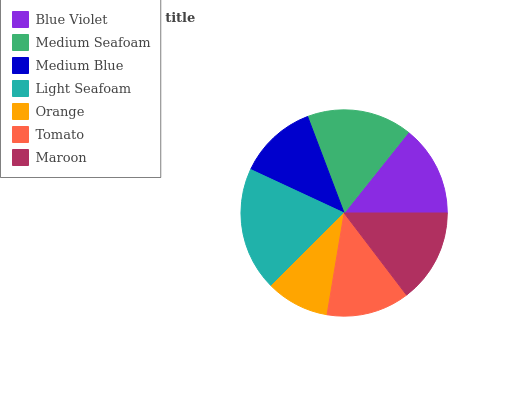Is Orange the minimum?
Answer yes or no. Yes. Is Light Seafoam the maximum?
Answer yes or no. Yes. Is Medium Seafoam the minimum?
Answer yes or no. No. Is Medium Seafoam the maximum?
Answer yes or no. No. Is Medium Seafoam greater than Blue Violet?
Answer yes or no. Yes. Is Blue Violet less than Medium Seafoam?
Answer yes or no. Yes. Is Blue Violet greater than Medium Seafoam?
Answer yes or no. No. Is Medium Seafoam less than Blue Violet?
Answer yes or no. No. Is Blue Violet the high median?
Answer yes or no. Yes. Is Blue Violet the low median?
Answer yes or no. Yes. Is Medium Seafoam the high median?
Answer yes or no. No. Is Medium Seafoam the low median?
Answer yes or no. No. 